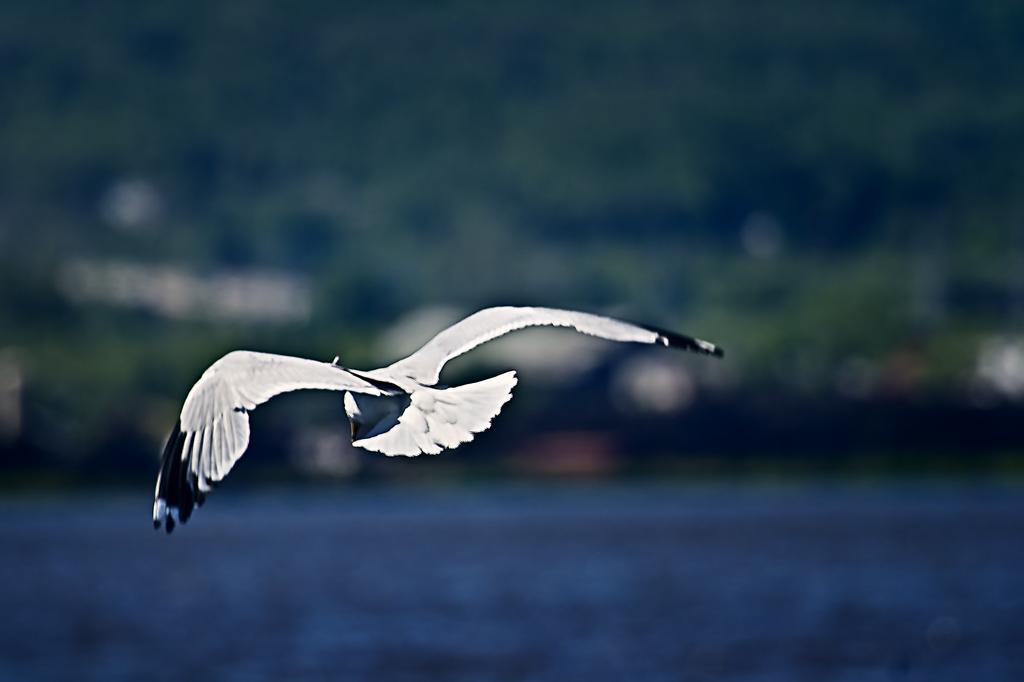Could you give a brief overview of what you see in this image? In the middle I can see a bird is flying in the air. At the bottom I can see water. In the background I can see trees. This image is taken may be in the evening. 